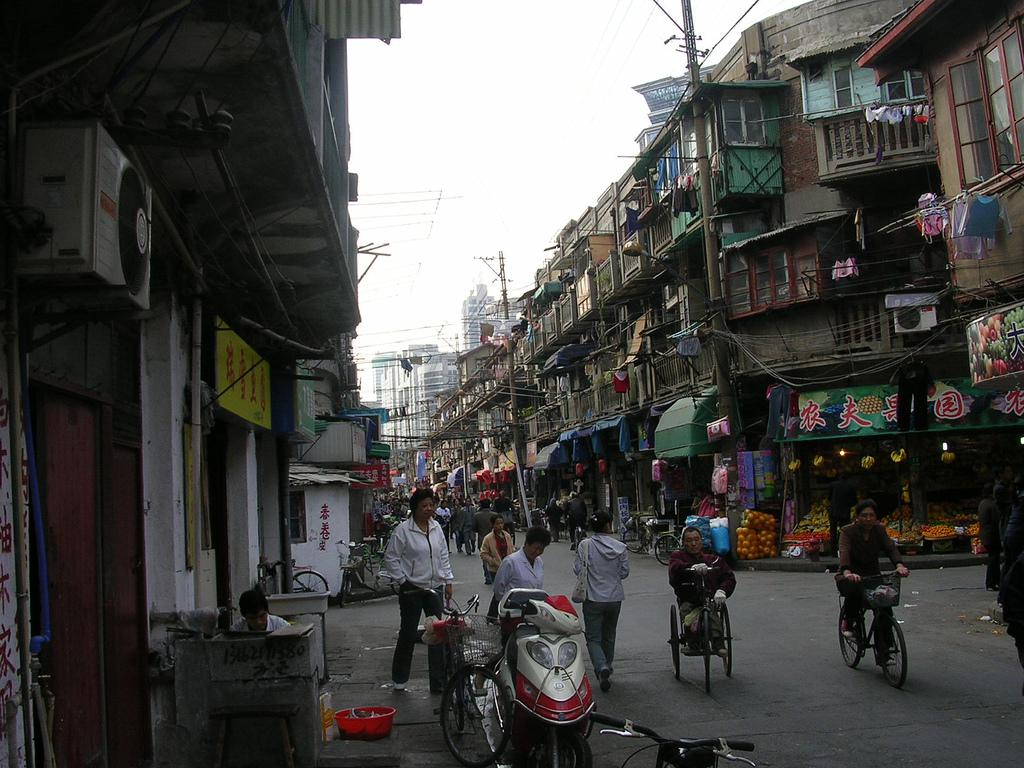Question: who is riding down the busy streets of hong kong?
Choices:
A. A motorcyclist.
B. A biker delivery driver.
C. Bicycle racers.
D. Skateboarders.
Answer with the letter. Answer: B Question: what is on a building?
Choices:
A. A flag.
B. A yellow sign with red lettering.
C. A window.
D. A door.
Answer with the letter. Answer: B Question: how many bikes are there?
Choices:
A. One.
B. Two.
C. Four.
D. Three.
Answer with the letter. Answer: D Question: what is the street made of?
Choices:
A. Tar.
B. Rocks and dirt.
C. Concrete.
D. Cement.
Answer with the letter. Answer: C Question: how many power line poles are there?
Choices:
A. Three poles.
B. One pole.
C. Two poles.
D. Four poles.
Answer with the letter. Answer: A Question: what is being sold on the right corner?
Choices:
A. Oranges and strawberries.
B. Snow cones.
C. Water.
D. Produce.
Answer with the letter. Answer: D Question: how many floors is the building on the right?
Choices:
A. One floor.
B. Two floors.
C. Three floors.
D. Four floors.
Answer with the letter. Answer: C Question: what is on the pole?
Choices:
A. A sign.
B. Clothes.
C. A tethered ball.
D. A hook.
Answer with the letter. Answer: B Question: what is the person riding?
Choices:
A. A three-wheeled bike.
B. A bicycle.
C. A unicycle.
D. A moped.
Answer with the letter. Answer: A Question: where are the people riding their bikes?
Choices:
A. On a road.
B. On a bike trail.
C. In a street of a run down area.
D. On a sidewalk.
Answer with the letter. Answer: C Question: what does the man park outside while he shops for groceries?
Choices:
A. His car.
B. His bike.
C. His scooter.
D. His motorcycle.
Answer with the letter. Answer: D Question: what color motorcycle is parked on the street?
Choices:
A. Blue and white.
B. Black.
C. Red and silver.
D. Red.
Answer with the letter. Answer: C Question: how tall are the buildings?
Choices:
A. 2 stories tall.
B. 3 stories tall.
C. 5 stories tall.
D. 4 stories tall.
Answer with the letter. Answer: B Question: what can be seen in the background?
Choices:
A. Mountains.
B. Trees.
C. High-rise buildings.
D. Hills.
Answer with the letter. Answer: C Question: what is overcast?
Choices:
A. The sky.
B. His mood.
C. The scene.
D. The lighting.
Answer with the letter. Answer: C Question: what was taken outdoor?
Choices:
A. Dog.
B. Photo.
C. Video.
D. Children.
Answer with the letter. Answer: B 